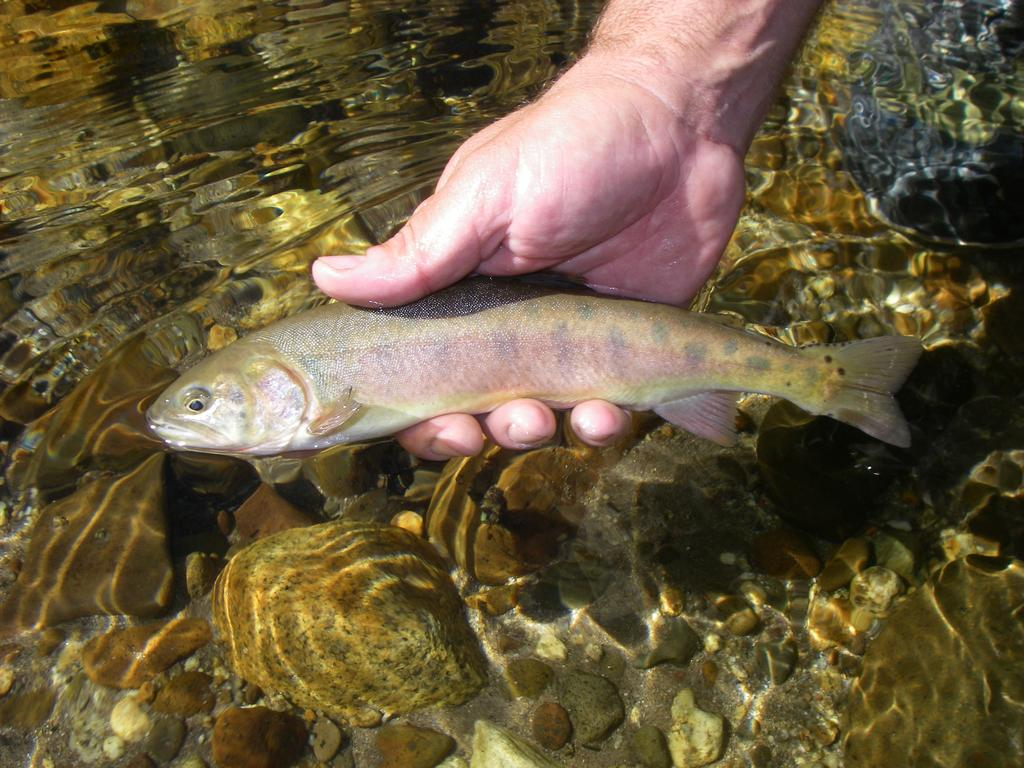What type of animal is in the image? There is a fish in the image. How is the fish being held in the image? The fish is being held by a human. What is the environment in which the fish is located? There is water visible in the image. What type of game is being played with the fish in the image? There is no game being played with the fish in the image; it is simply being held by a human. Can you see a drum in the image? There is no drum present in the image. 